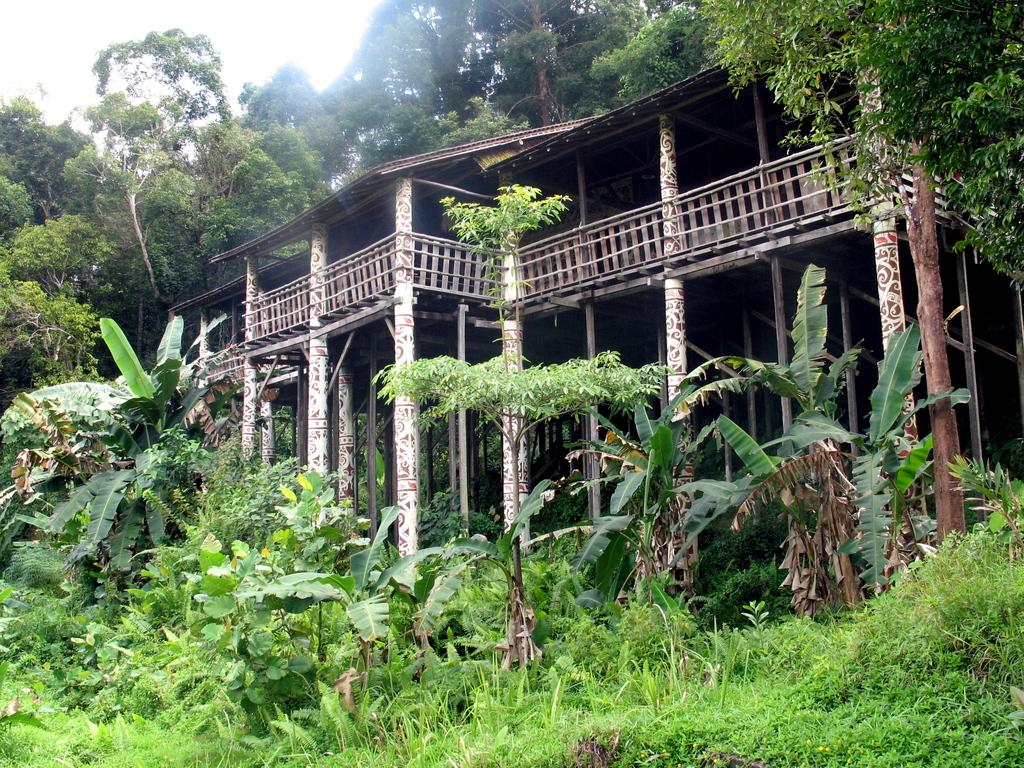What type of structure can be seen in the image? There is a building in the image. What natural elements are visible in the image? Trees and plants are visible in the image. What part of the natural environment can be seen in the image? The sky is visible in the top left corner of the image. What type of advice can be seen written on the building in the image? There is no advice written on the building in the image. Can you see a toad sitting on the plants in the image? There is no toad present in the image. 